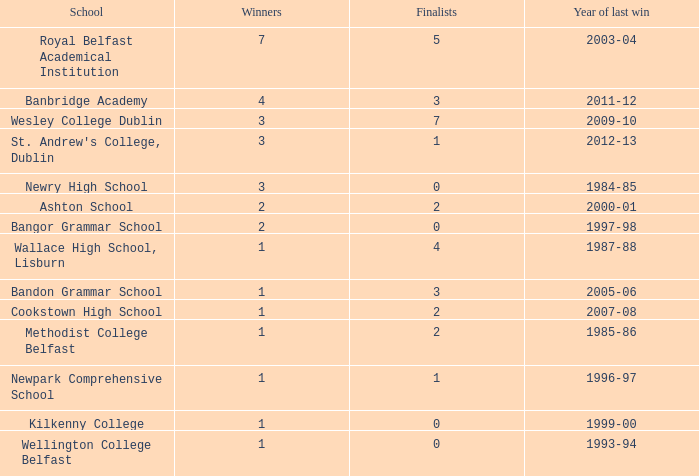What are the names with a finalist score of 2? Ashton School, Cookstown High School, Methodist College Belfast. 